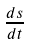<formula> <loc_0><loc_0><loc_500><loc_500>\frac { d s } { d t }</formula> 